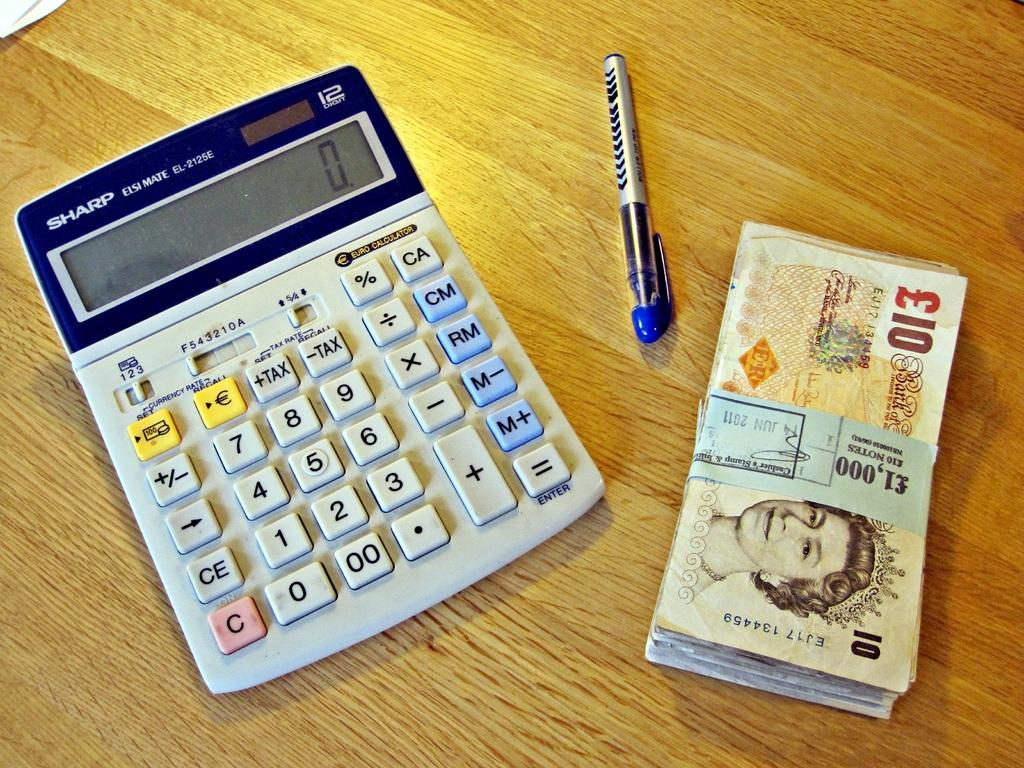<image>
Present a compact description of the photo's key features. A calculator, a pen together wuth a bundle ot £10 notes making up £1,000 